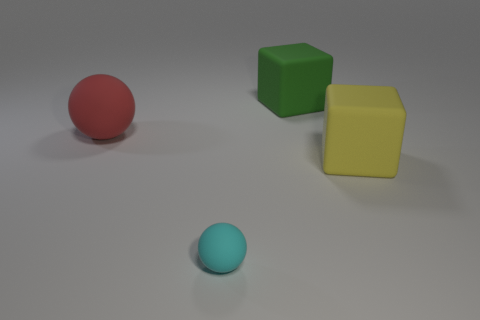Is the number of rubber objects that are behind the yellow thing greater than the number of small blue cubes?
Ensure brevity in your answer.  Yes. What material is the green object?
Your answer should be compact. Rubber. What number of green objects have the same size as the red thing?
Offer a very short reply. 1. Are there the same number of large yellow rubber things to the left of the big rubber ball and matte balls that are behind the big yellow rubber object?
Offer a very short reply. No. Is the yellow block made of the same material as the tiny cyan object?
Give a very brief answer. Yes. Is there a yellow rubber thing behind the big block behind the yellow matte thing?
Give a very brief answer. No. Is there a blue rubber object of the same shape as the tiny cyan thing?
Ensure brevity in your answer.  No. Is the small matte object the same color as the large rubber ball?
Provide a succinct answer. No. The large cube that is behind the large block that is in front of the red rubber object is made of what material?
Provide a short and direct response. Rubber. The green matte cube has what size?
Make the answer very short. Large. 